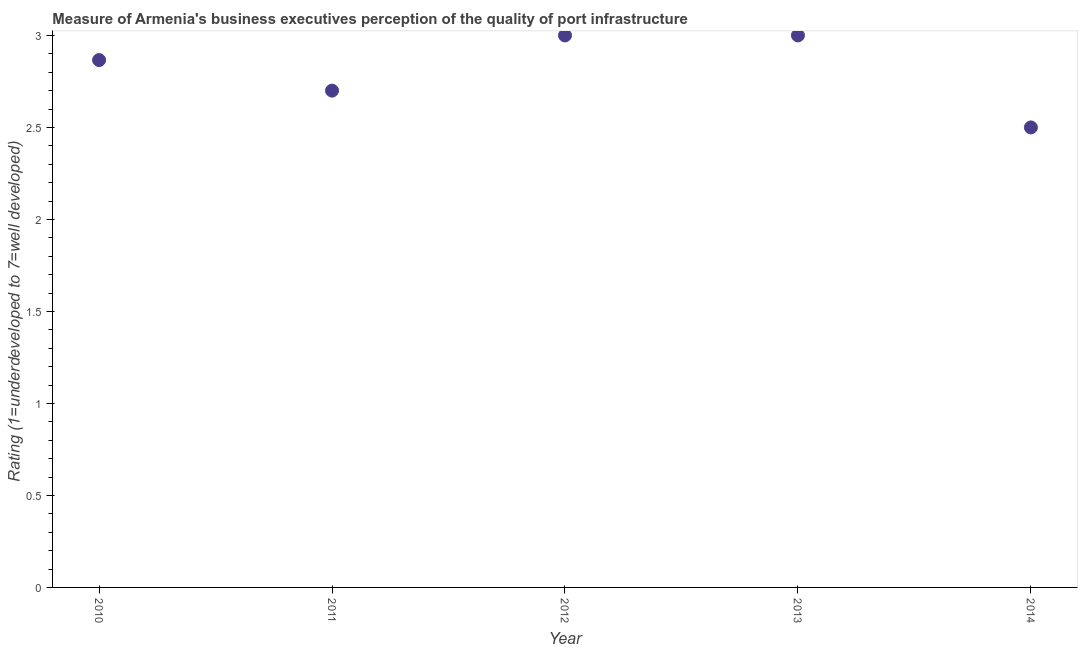Across all years, what is the maximum rating measuring quality of port infrastructure?
Give a very brief answer. 3. In which year was the rating measuring quality of port infrastructure maximum?
Offer a terse response. 2012. In which year was the rating measuring quality of port infrastructure minimum?
Give a very brief answer. 2014. What is the sum of the rating measuring quality of port infrastructure?
Provide a succinct answer. 14.07. What is the difference between the rating measuring quality of port infrastructure in 2010 and 2013?
Ensure brevity in your answer.  -0.13. What is the average rating measuring quality of port infrastructure per year?
Your answer should be compact. 2.81. What is the median rating measuring quality of port infrastructure?
Offer a terse response. 2.87. Do a majority of the years between 2013 and 2014 (inclusive) have rating measuring quality of port infrastructure greater than 1.3 ?
Make the answer very short. Yes. What is the ratio of the rating measuring quality of port infrastructure in 2010 to that in 2013?
Your answer should be very brief. 0.96. Is the rating measuring quality of port infrastructure in 2010 less than that in 2013?
Your response must be concise. Yes. Does the rating measuring quality of port infrastructure monotonically increase over the years?
Provide a short and direct response. No. What is the difference between two consecutive major ticks on the Y-axis?
Offer a very short reply. 0.5. Does the graph contain any zero values?
Offer a terse response. No. Does the graph contain grids?
Offer a terse response. No. What is the title of the graph?
Make the answer very short. Measure of Armenia's business executives perception of the quality of port infrastructure. What is the label or title of the Y-axis?
Offer a terse response. Rating (1=underdeveloped to 7=well developed) . What is the Rating (1=underdeveloped to 7=well developed)  in 2010?
Your answer should be compact. 2.87. What is the Rating (1=underdeveloped to 7=well developed)  in 2011?
Your answer should be very brief. 2.7. What is the Rating (1=underdeveloped to 7=well developed)  in 2012?
Keep it short and to the point. 3. What is the Rating (1=underdeveloped to 7=well developed)  in 2013?
Offer a terse response. 3. What is the difference between the Rating (1=underdeveloped to 7=well developed)  in 2010 and 2011?
Ensure brevity in your answer.  0.17. What is the difference between the Rating (1=underdeveloped to 7=well developed)  in 2010 and 2012?
Offer a terse response. -0.13. What is the difference between the Rating (1=underdeveloped to 7=well developed)  in 2010 and 2013?
Keep it short and to the point. -0.13. What is the difference between the Rating (1=underdeveloped to 7=well developed)  in 2010 and 2014?
Provide a short and direct response. 0.37. What is the difference between the Rating (1=underdeveloped to 7=well developed)  in 2011 and 2012?
Keep it short and to the point. -0.3. What is the difference between the Rating (1=underdeveloped to 7=well developed)  in 2011 and 2013?
Offer a terse response. -0.3. What is the difference between the Rating (1=underdeveloped to 7=well developed)  in 2011 and 2014?
Your response must be concise. 0.2. What is the difference between the Rating (1=underdeveloped to 7=well developed)  in 2013 and 2014?
Offer a very short reply. 0.5. What is the ratio of the Rating (1=underdeveloped to 7=well developed)  in 2010 to that in 2011?
Make the answer very short. 1.06. What is the ratio of the Rating (1=underdeveloped to 7=well developed)  in 2010 to that in 2012?
Offer a terse response. 0.95. What is the ratio of the Rating (1=underdeveloped to 7=well developed)  in 2010 to that in 2013?
Your answer should be compact. 0.95. What is the ratio of the Rating (1=underdeveloped to 7=well developed)  in 2010 to that in 2014?
Offer a terse response. 1.15. What is the ratio of the Rating (1=underdeveloped to 7=well developed)  in 2011 to that in 2013?
Your answer should be compact. 0.9. What is the ratio of the Rating (1=underdeveloped to 7=well developed)  in 2011 to that in 2014?
Keep it short and to the point. 1.08. What is the ratio of the Rating (1=underdeveloped to 7=well developed)  in 2012 to that in 2014?
Give a very brief answer. 1.2. What is the ratio of the Rating (1=underdeveloped to 7=well developed)  in 2013 to that in 2014?
Provide a succinct answer. 1.2. 